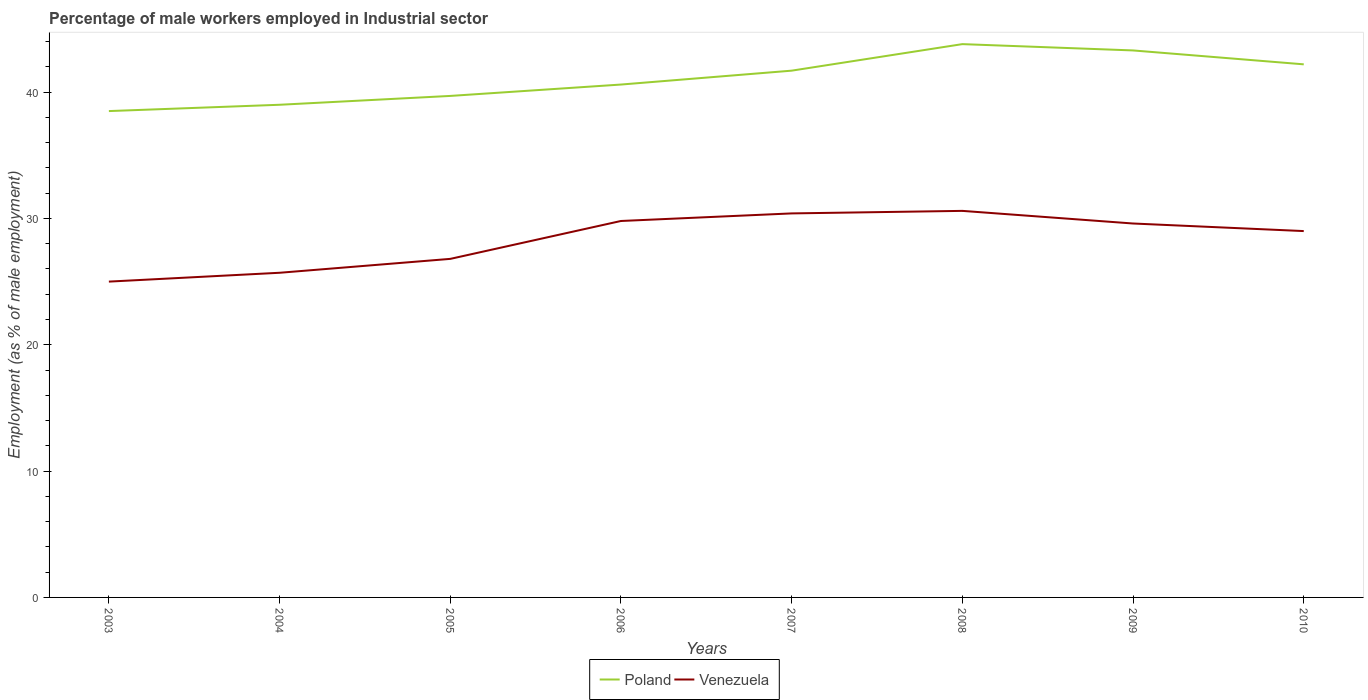How many different coloured lines are there?
Give a very brief answer. 2. Across all years, what is the maximum percentage of male workers employed in Industrial sector in Venezuela?
Give a very brief answer. 25. What is the total percentage of male workers employed in Industrial sector in Venezuela in the graph?
Make the answer very short. -3. What is the difference between the highest and the second highest percentage of male workers employed in Industrial sector in Venezuela?
Offer a terse response. 5.6. What is the difference between the highest and the lowest percentage of male workers employed in Industrial sector in Poland?
Offer a terse response. 4. How many lines are there?
Provide a succinct answer. 2. Are the values on the major ticks of Y-axis written in scientific E-notation?
Ensure brevity in your answer.  No. Does the graph contain grids?
Keep it short and to the point. No. Where does the legend appear in the graph?
Provide a succinct answer. Bottom center. What is the title of the graph?
Ensure brevity in your answer.  Percentage of male workers employed in Industrial sector. Does "United Kingdom" appear as one of the legend labels in the graph?
Offer a terse response. No. What is the label or title of the Y-axis?
Ensure brevity in your answer.  Employment (as % of male employment). What is the Employment (as % of male employment) in Poland in 2003?
Offer a very short reply. 38.5. What is the Employment (as % of male employment) in Venezuela in 2003?
Give a very brief answer. 25. What is the Employment (as % of male employment) in Venezuela in 2004?
Provide a short and direct response. 25.7. What is the Employment (as % of male employment) of Poland in 2005?
Make the answer very short. 39.7. What is the Employment (as % of male employment) in Venezuela in 2005?
Ensure brevity in your answer.  26.8. What is the Employment (as % of male employment) in Poland in 2006?
Offer a terse response. 40.6. What is the Employment (as % of male employment) in Venezuela in 2006?
Provide a short and direct response. 29.8. What is the Employment (as % of male employment) in Poland in 2007?
Offer a very short reply. 41.7. What is the Employment (as % of male employment) of Venezuela in 2007?
Make the answer very short. 30.4. What is the Employment (as % of male employment) in Poland in 2008?
Provide a short and direct response. 43.8. What is the Employment (as % of male employment) in Venezuela in 2008?
Make the answer very short. 30.6. What is the Employment (as % of male employment) of Poland in 2009?
Your response must be concise. 43.3. What is the Employment (as % of male employment) in Venezuela in 2009?
Offer a very short reply. 29.6. What is the Employment (as % of male employment) of Poland in 2010?
Keep it short and to the point. 42.2. Across all years, what is the maximum Employment (as % of male employment) in Poland?
Your answer should be compact. 43.8. Across all years, what is the maximum Employment (as % of male employment) in Venezuela?
Provide a succinct answer. 30.6. Across all years, what is the minimum Employment (as % of male employment) in Poland?
Provide a short and direct response. 38.5. Across all years, what is the minimum Employment (as % of male employment) of Venezuela?
Your answer should be compact. 25. What is the total Employment (as % of male employment) in Poland in the graph?
Your response must be concise. 328.8. What is the total Employment (as % of male employment) in Venezuela in the graph?
Give a very brief answer. 226.9. What is the difference between the Employment (as % of male employment) of Poland in 2003 and that in 2004?
Offer a very short reply. -0.5. What is the difference between the Employment (as % of male employment) of Venezuela in 2003 and that in 2004?
Offer a very short reply. -0.7. What is the difference between the Employment (as % of male employment) in Venezuela in 2003 and that in 2005?
Your answer should be compact. -1.8. What is the difference between the Employment (as % of male employment) of Poland in 2003 and that in 2006?
Ensure brevity in your answer.  -2.1. What is the difference between the Employment (as % of male employment) in Venezuela in 2003 and that in 2006?
Make the answer very short. -4.8. What is the difference between the Employment (as % of male employment) of Poland in 2003 and that in 2007?
Offer a terse response. -3.2. What is the difference between the Employment (as % of male employment) of Poland in 2003 and that in 2009?
Your answer should be compact. -4.8. What is the difference between the Employment (as % of male employment) in Poland in 2003 and that in 2010?
Ensure brevity in your answer.  -3.7. What is the difference between the Employment (as % of male employment) of Venezuela in 2003 and that in 2010?
Give a very brief answer. -4. What is the difference between the Employment (as % of male employment) in Poland in 2004 and that in 2006?
Keep it short and to the point. -1.6. What is the difference between the Employment (as % of male employment) of Venezuela in 2004 and that in 2006?
Your answer should be compact. -4.1. What is the difference between the Employment (as % of male employment) of Venezuela in 2004 and that in 2007?
Offer a terse response. -4.7. What is the difference between the Employment (as % of male employment) of Venezuela in 2004 and that in 2010?
Ensure brevity in your answer.  -3.3. What is the difference between the Employment (as % of male employment) of Poland in 2005 and that in 2007?
Provide a short and direct response. -2. What is the difference between the Employment (as % of male employment) in Venezuela in 2005 and that in 2008?
Your answer should be compact. -3.8. What is the difference between the Employment (as % of male employment) in Venezuela in 2005 and that in 2009?
Offer a terse response. -2.8. What is the difference between the Employment (as % of male employment) of Poland in 2005 and that in 2010?
Provide a succinct answer. -2.5. What is the difference between the Employment (as % of male employment) of Poland in 2006 and that in 2007?
Your response must be concise. -1.1. What is the difference between the Employment (as % of male employment) of Poland in 2006 and that in 2008?
Give a very brief answer. -3.2. What is the difference between the Employment (as % of male employment) of Poland in 2006 and that in 2009?
Provide a short and direct response. -2.7. What is the difference between the Employment (as % of male employment) of Venezuela in 2006 and that in 2009?
Your response must be concise. 0.2. What is the difference between the Employment (as % of male employment) of Poland in 2007 and that in 2009?
Your answer should be very brief. -1.6. What is the difference between the Employment (as % of male employment) in Poland in 2007 and that in 2010?
Ensure brevity in your answer.  -0.5. What is the difference between the Employment (as % of male employment) of Poland in 2008 and that in 2009?
Your answer should be compact. 0.5. What is the difference between the Employment (as % of male employment) of Venezuela in 2008 and that in 2009?
Ensure brevity in your answer.  1. What is the difference between the Employment (as % of male employment) in Poland in 2008 and that in 2010?
Keep it short and to the point. 1.6. What is the difference between the Employment (as % of male employment) of Venezuela in 2008 and that in 2010?
Ensure brevity in your answer.  1.6. What is the difference between the Employment (as % of male employment) of Venezuela in 2009 and that in 2010?
Your answer should be very brief. 0.6. What is the difference between the Employment (as % of male employment) in Poland in 2003 and the Employment (as % of male employment) in Venezuela in 2005?
Keep it short and to the point. 11.7. What is the difference between the Employment (as % of male employment) of Poland in 2003 and the Employment (as % of male employment) of Venezuela in 2007?
Provide a succinct answer. 8.1. What is the difference between the Employment (as % of male employment) in Poland in 2003 and the Employment (as % of male employment) in Venezuela in 2008?
Give a very brief answer. 7.9. What is the difference between the Employment (as % of male employment) of Poland in 2003 and the Employment (as % of male employment) of Venezuela in 2009?
Keep it short and to the point. 8.9. What is the difference between the Employment (as % of male employment) of Poland in 2004 and the Employment (as % of male employment) of Venezuela in 2007?
Make the answer very short. 8.6. What is the difference between the Employment (as % of male employment) of Poland in 2004 and the Employment (as % of male employment) of Venezuela in 2009?
Make the answer very short. 9.4. What is the difference between the Employment (as % of male employment) of Poland in 2005 and the Employment (as % of male employment) of Venezuela in 2007?
Your answer should be compact. 9.3. What is the difference between the Employment (as % of male employment) in Poland in 2005 and the Employment (as % of male employment) in Venezuela in 2008?
Give a very brief answer. 9.1. What is the difference between the Employment (as % of male employment) in Poland in 2005 and the Employment (as % of male employment) in Venezuela in 2009?
Your answer should be very brief. 10.1. What is the difference between the Employment (as % of male employment) in Poland in 2006 and the Employment (as % of male employment) in Venezuela in 2007?
Your answer should be compact. 10.2. What is the difference between the Employment (as % of male employment) of Poland in 2006 and the Employment (as % of male employment) of Venezuela in 2008?
Your answer should be compact. 10. What is the difference between the Employment (as % of male employment) of Poland in 2006 and the Employment (as % of male employment) of Venezuela in 2009?
Keep it short and to the point. 11. What is the difference between the Employment (as % of male employment) in Poland in 2007 and the Employment (as % of male employment) in Venezuela in 2009?
Keep it short and to the point. 12.1. What is the difference between the Employment (as % of male employment) in Poland in 2007 and the Employment (as % of male employment) in Venezuela in 2010?
Make the answer very short. 12.7. What is the difference between the Employment (as % of male employment) of Poland in 2008 and the Employment (as % of male employment) of Venezuela in 2009?
Provide a succinct answer. 14.2. What is the average Employment (as % of male employment) in Poland per year?
Provide a succinct answer. 41.1. What is the average Employment (as % of male employment) in Venezuela per year?
Make the answer very short. 28.36. In the year 2003, what is the difference between the Employment (as % of male employment) of Poland and Employment (as % of male employment) of Venezuela?
Give a very brief answer. 13.5. In the year 2004, what is the difference between the Employment (as % of male employment) of Poland and Employment (as % of male employment) of Venezuela?
Offer a very short reply. 13.3. In the year 2005, what is the difference between the Employment (as % of male employment) of Poland and Employment (as % of male employment) of Venezuela?
Keep it short and to the point. 12.9. In the year 2010, what is the difference between the Employment (as % of male employment) in Poland and Employment (as % of male employment) in Venezuela?
Make the answer very short. 13.2. What is the ratio of the Employment (as % of male employment) in Poland in 2003 to that in 2004?
Keep it short and to the point. 0.99. What is the ratio of the Employment (as % of male employment) of Venezuela in 2003 to that in 2004?
Your answer should be very brief. 0.97. What is the ratio of the Employment (as % of male employment) of Poland in 2003 to that in 2005?
Your answer should be very brief. 0.97. What is the ratio of the Employment (as % of male employment) in Venezuela in 2003 to that in 2005?
Keep it short and to the point. 0.93. What is the ratio of the Employment (as % of male employment) in Poland in 2003 to that in 2006?
Your answer should be very brief. 0.95. What is the ratio of the Employment (as % of male employment) in Venezuela in 2003 to that in 2006?
Your answer should be very brief. 0.84. What is the ratio of the Employment (as % of male employment) in Poland in 2003 to that in 2007?
Provide a succinct answer. 0.92. What is the ratio of the Employment (as % of male employment) in Venezuela in 2003 to that in 2007?
Provide a succinct answer. 0.82. What is the ratio of the Employment (as % of male employment) of Poland in 2003 to that in 2008?
Make the answer very short. 0.88. What is the ratio of the Employment (as % of male employment) of Venezuela in 2003 to that in 2008?
Ensure brevity in your answer.  0.82. What is the ratio of the Employment (as % of male employment) in Poland in 2003 to that in 2009?
Make the answer very short. 0.89. What is the ratio of the Employment (as % of male employment) of Venezuela in 2003 to that in 2009?
Ensure brevity in your answer.  0.84. What is the ratio of the Employment (as % of male employment) of Poland in 2003 to that in 2010?
Your response must be concise. 0.91. What is the ratio of the Employment (as % of male employment) of Venezuela in 2003 to that in 2010?
Provide a short and direct response. 0.86. What is the ratio of the Employment (as % of male employment) of Poland in 2004 to that in 2005?
Keep it short and to the point. 0.98. What is the ratio of the Employment (as % of male employment) in Venezuela in 2004 to that in 2005?
Your answer should be very brief. 0.96. What is the ratio of the Employment (as % of male employment) of Poland in 2004 to that in 2006?
Provide a succinct answer. 0.96. What is the ratio of the Employment (as % of male employment) of Venezuela in 2004 to that in 2006?
Make the answer very short. 0.86. What is the ratio of the Employment (as % of male employment) of Poland in 2004 to that in 2007?
Offer a terse response. 0.94. What is the ratio of the Employment (as % of male employment) of Venezuela in 2004 to that in 2007?
Ensure brevity in your answer.  0.85. What is the ratio of the Employment (as % of male employment) in Poland in 2004 to that in 2008?
Ensure brevity in your answer.  0.89. What is the ratio of the Employment (as % of male employment) in Venezuela in 2004 to that in 2008?
Your answer should be very brief. 0.84. What is the ratio of the Employment (as % of male employment) of Poland in 2004 to that in 2009?
Provide a succinct answer. 0.9. What is the ratio of the Employment (as % of male employment) of Venezuela in 2004 to that in 2009?
Offer a terse response. 0.87. What is the ratio of the Employment (as % of male employment) in Poland in 2004 to that in 2010?
Make the answer very short. 0.92. What is the ratio of the Employment (as % of male employment) in Venezuela in 2004 to that in 2010?
Your answer should be compact. 0.89. What is the ratio of the Employment (as % of male employment) in Poland in 2005 to that in 2006?
Keep it short and to the point. 0.98. What is the ratio of the Employment (as % of male employment) in Venezuela in 2005 to that in 2006?
Give a very brief answer. 0.9. What is the ratio of the Employment (as % of male employment) of Venezuela in 2005 to that in 2007?
Provide a succinct answer. 0.88. What is the ratio of the Employment (as % of male employment) in Poland in 2005 to that in 2008?
Your answer should be very brief. 0.91. What is the ratio of the Employment (as % of male employment) of Venezuela in 2005 to that in 2008?
Your response must be concise. 0.88. What is the ratio of the Employment (as % of male employment) in Poland in 2005 to that in 2009?
Offer a terse response. 0.92. What is the ratio of the Employment (as % of male employment) of Venezuela in 2005 to that in 2009?
Keep it short and to the point. 0.91. What is the ratio of the Employment (as % of male employment) of Poland in 2005 to that in 2010?
Provide a succinct answer. 0.94. What is the ratio of the Employment (as % of male employment) in Venezuela in 2005 to that in 2010?
Your response must be concise. 0.92. What is the ratio of the Employment (as % of male employment) in Poland in 2006 to that in 2007?
Offer a terse response. 0.97. What is the ratio of the Employment (as % of male employment) of Venezuela in 2006 to that in 2007?
Provide a succinct answer. 0.98. What is the ratio of the Employment (as % of male employment) in Poland in 2006 to that in 2008?
Offer a very short reply. 0.93. What is the ratio of the Employment (as % of male employment) of Venezuela in 2006 to that in 2008?
Ensure brevity in your answer.  0.97. What is the ratio of the Employment (as % of male employment) in Poland in 2006 to that in 2009?
Provide a short and direct response. 0.94. What is the ratio of the Employment (as % of male employment) in Venezuela in 2006 to that in 2009?
Your answer should be compact. 1.01. What is the ratio of the Employment (as % of male employment) of Poland in 2006 to that in 2010?
Keep it short and to the point. 0.96. What is the ratio of the Employment (as % of male employment) in Venezuela in 2006 to that in 2010?
Give a very brief answer. 1.03. What is the ratio of the Employment (as % of male employment) of Poland in 2007 to that in 2008?
Provide a succinct answer. 0.95. What is the ratio of the Employment (as % of male employment) of Venezuela in 2007 to that in 2008?
Keep it short and to the point. 0.99. What is the ratio of the Employment (as % of male employment) of Venezuela in 2007 to that in 2009?
Offer a terse response. 1.03. What is the ratio of the Employment (as % of male employment) of Venezuela in 2007 to that in 2010?
Give a very brief answer. 1.05. What is the ratio of the Employment (as % of male employment) in Poland in 2008 to that in 2009?
Give a very brief answer. 1.01. What is the ratio of the Employment (as % of male employment) in Venezuela in 2008 to that in 2009?
Offer a very short reply. 1.03. What is the ratio of the Employment (as % of male employment) in Poland in 2008 to that in 2010?
Your response must be concise. 1.04. What is the ratio of the Employment (as % of male employment) of Venezuela in 2008 to that in 2010?
Ensure brevity in your answer.  1.06. What is the ratio of the Employment (as % of male employment) in Poland in 2009 to that in 2010?
Offer a very short reply. 1.03. What is the ratio of the Employment (as % of male employment) of Venezuela in 2009 to that in 2010?
Your answer should be compact. 1.02. What is the difference between the highest and the lowest Employment (as % of male employment) in Venezuela?
Keep it short and to the point. 5.6. 